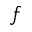<formula> <loc_0><loc_0><loc_500><loc_500>f</formula> 